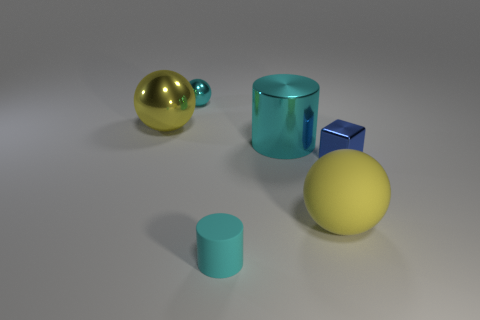Subtract all shiny spheres. How many spheres are left? 1 Subtract all purple cylinders. How many yellow spheres are left? 2 Subtract all yellow spheres. How many spheres are left? 1 Add 2 cyan rubber cylinders. How many objects exist? 8 Subtract all cylinders. How many objects are left? 4 Subtract all purple spheres. Subtract all brown cylinders. How many spheres are left? 3 Add 2 large yellow matte things. How many large yellow matte things are left? 3 Add 6 matte cylinders. How many matte cylinders exist? 7 Subtract 0 red balls. How many objects are left? 6 Subtract all small cyan balls. Subtract all tiny blue metallic objects. How many objects are left? 4 